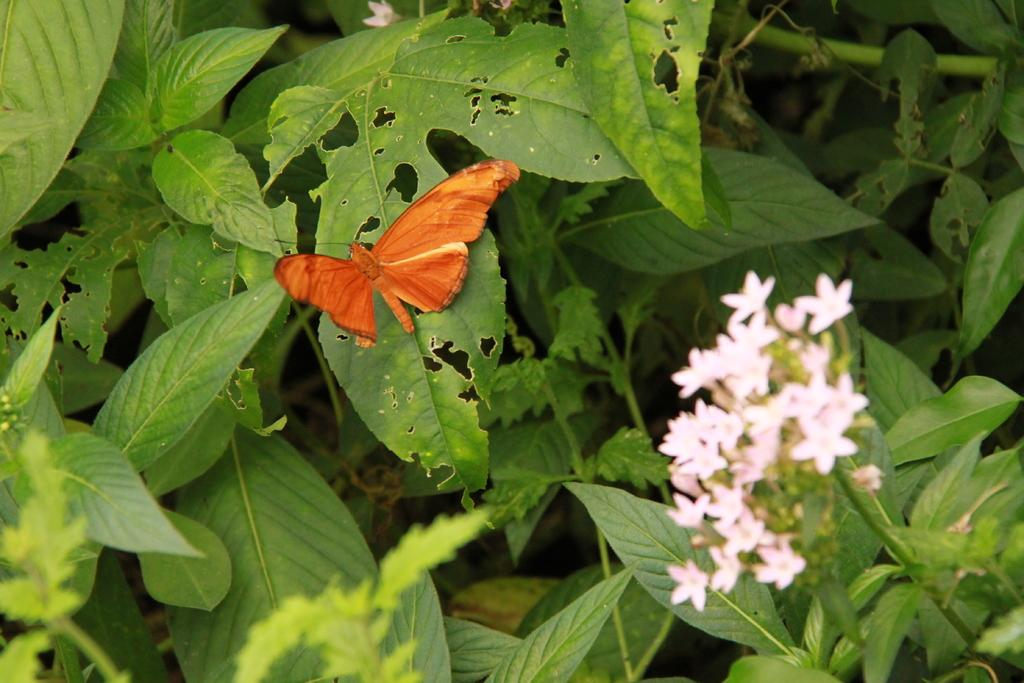What is on the leaf in the image? There is a butterfly on a leaf in the image. What type of plants can be seen in the image? Flower plants are present in the image. What type of prose is being recited by the butterfly in the image? There is no indication in the image that the butterfly is reciting any prose. 